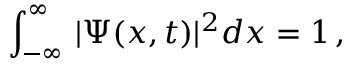Convert formula to latex. <formula><loc_0><loc_0><loc_500><loc_500>\, \int _ { - \infty } ^ { \infty } \, | \Psi ( x , t ) | ^ { 2 } d x = 1 \, ,</formula> 